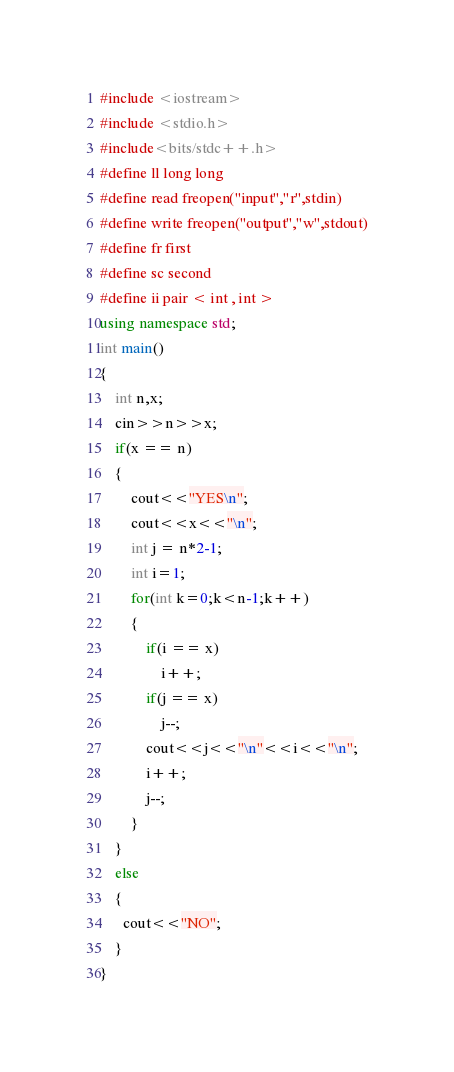<code> <loc_0><loc_0><loc_500><loc_500><_C++_>#include <iostream>
#include <stdio.h>
#include<bits/stdc++.h>
#define ll long long
#define read freopen("input","r",stdin)
#define write freopen("output","w",stdout)
#define fr first
#define sc second
#define ii pair < int , int >
using namespace std;
int main()
{
    int n,x;
    cin>>n>>x;
    if(x == n)
    {
        cout<<"YES\n";
        cout<<x<<"\n";
        int j = n*2-1;
        int i=1;
        for(int k=0;k<n-1;k++)
        {
            if(i == x)
                i++;
            if(j == x)
                j--;
            cout<<j<<"\n"<<i<<"\n";
            i++;
            j--;
        }
    }
    else
    {
      cout<<"NO";
    }
}
</code> 